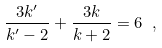Convert formula to latex. <formula><loc_0><loc_0><loc_500><loc_500>\frac { 3 k ^ { \prime } } { k ^ { \prime } - 2 } + \frac { 3 k } { k + 2 } = 6 \ , \label l { e q \colon k c o n d i t i o n }</formula> 